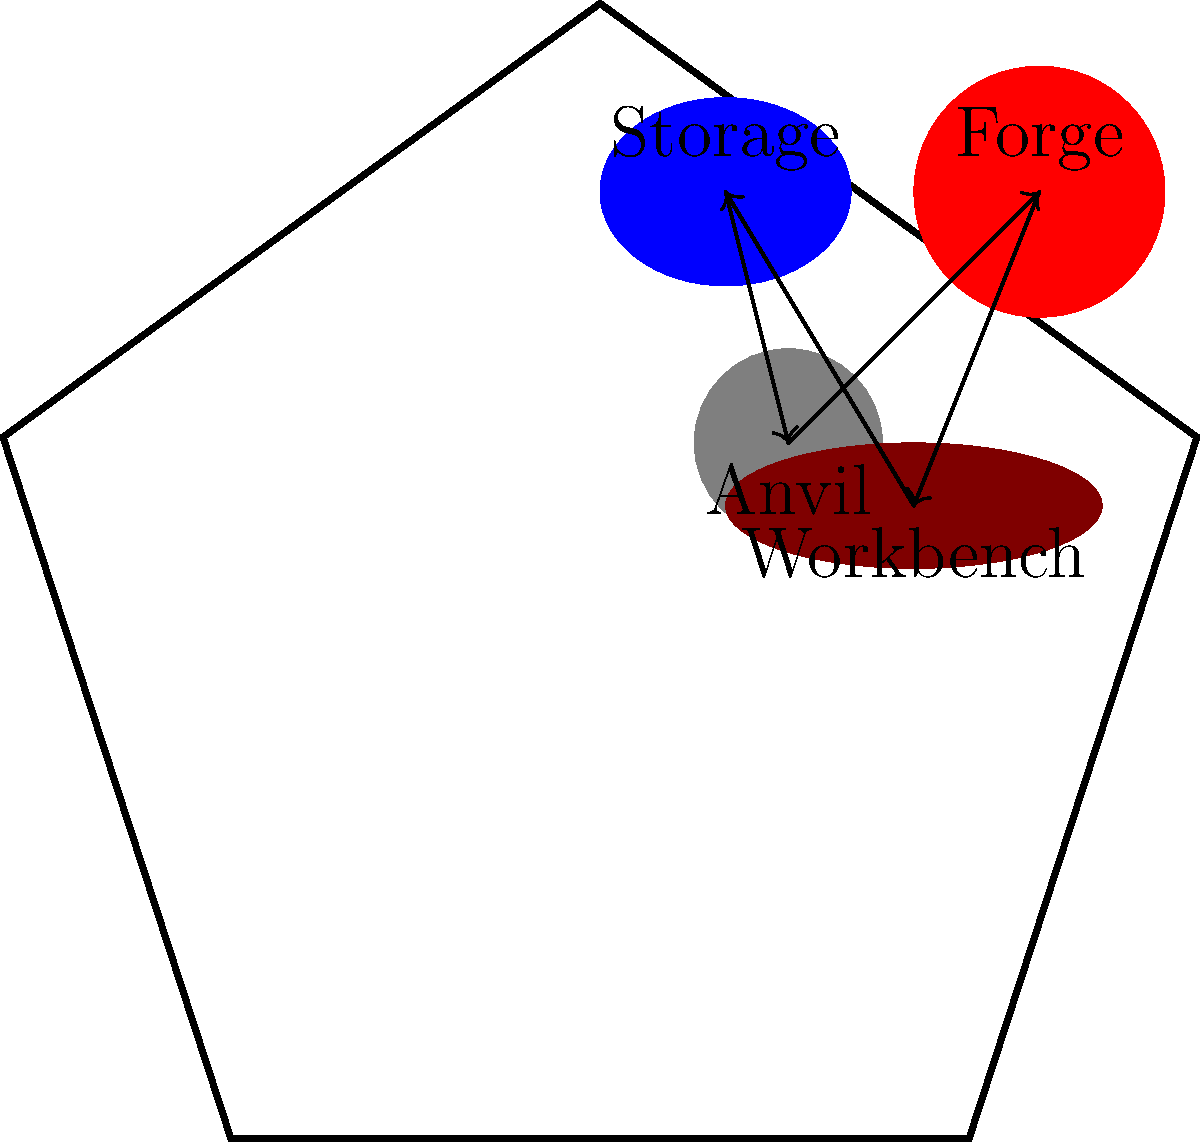Given the layout of a blacksmith's workshop shown in the diagram, which arrangement of tools and materials would maximize efficiency in the workflow for crafting a firearm barrel? Consider the sequence of steps: forging, shaping on the anvil, refining at the workbench, and storing materials. To determine the most efficient arrangement, we need to analyze the workflow for crafting a firearm barrel:

1. The process typically starts at the forge, where the metal is heated.
2. Next, the hot metal is shaped on the anvil.
3. Further refinement and precision work is done at the workbench.
4. Materials and finished parts are stored in the storage area.

The ideal arrangement should minimize movement between stations. Let's examine the current layout:

1. The forge is positioned opposite the anvil, requiring a long movement.
2. The workbench is closer to the anvil but far from the forge.
3. The storage area is opposite the workbench, creating another long movement.

To improve efficiency, we should arrange the stations in a clockwise or counterclockwise sequence:

Forge → Anvil → Workbench → Storage

This arrangement would create a smooth, circular workflow with minimal back-and-forth movement. The most efficient layout would be:

1. Place the forge and anvil close to each other.
2. Position the workbench next to the anvil.
3. Locate the storage area between the workbench and the forge.

This circular arrangement allows for a continuous workflow, reducing time and energy spent moving between stations.
Answer: Circular arrangement: Forge → Anvil → Workbench → Storage 